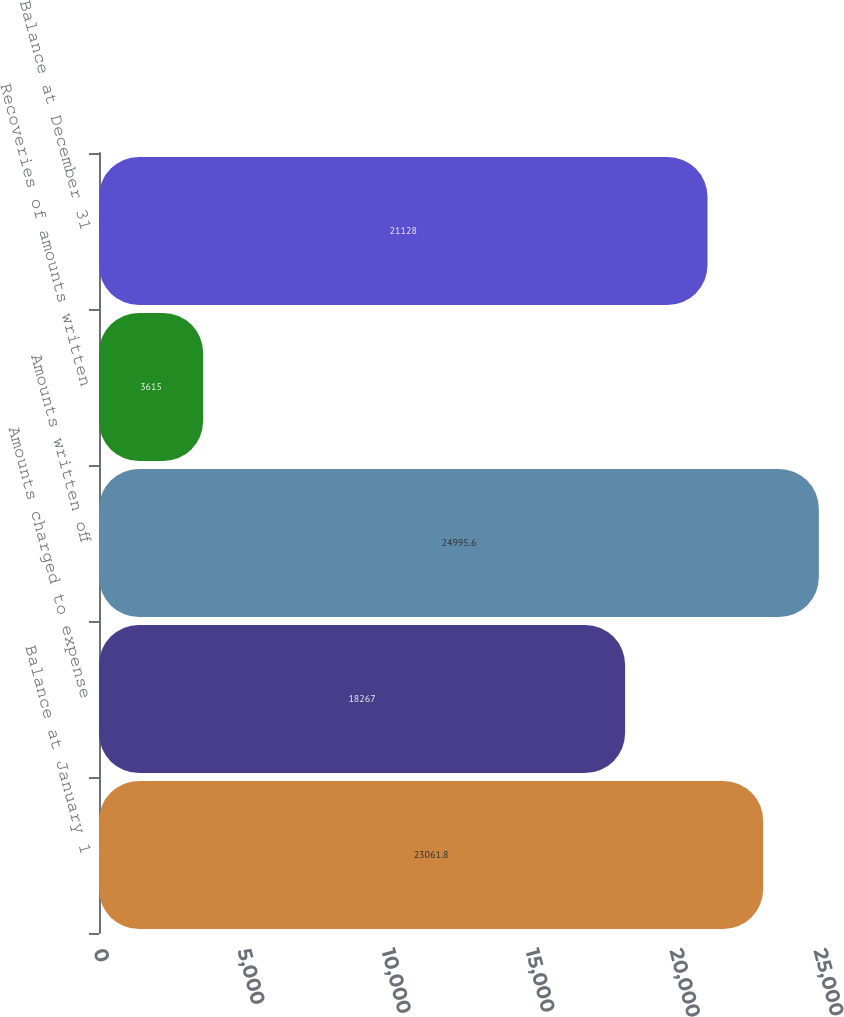Convert chart. <chart><loc_0><loc_0><loc_500><loc_500><bar_chart><fcel>Balance at January 1<fcel>Amounts charged to expense<fcel>Amounts written off<fcel>Recoveries of amounts written<fcel>Balance at December 31<nl><fcel>23061.8<fcel>18267<fcel>24995.6<fcel>3615<fcel>21128<nl></chart> 